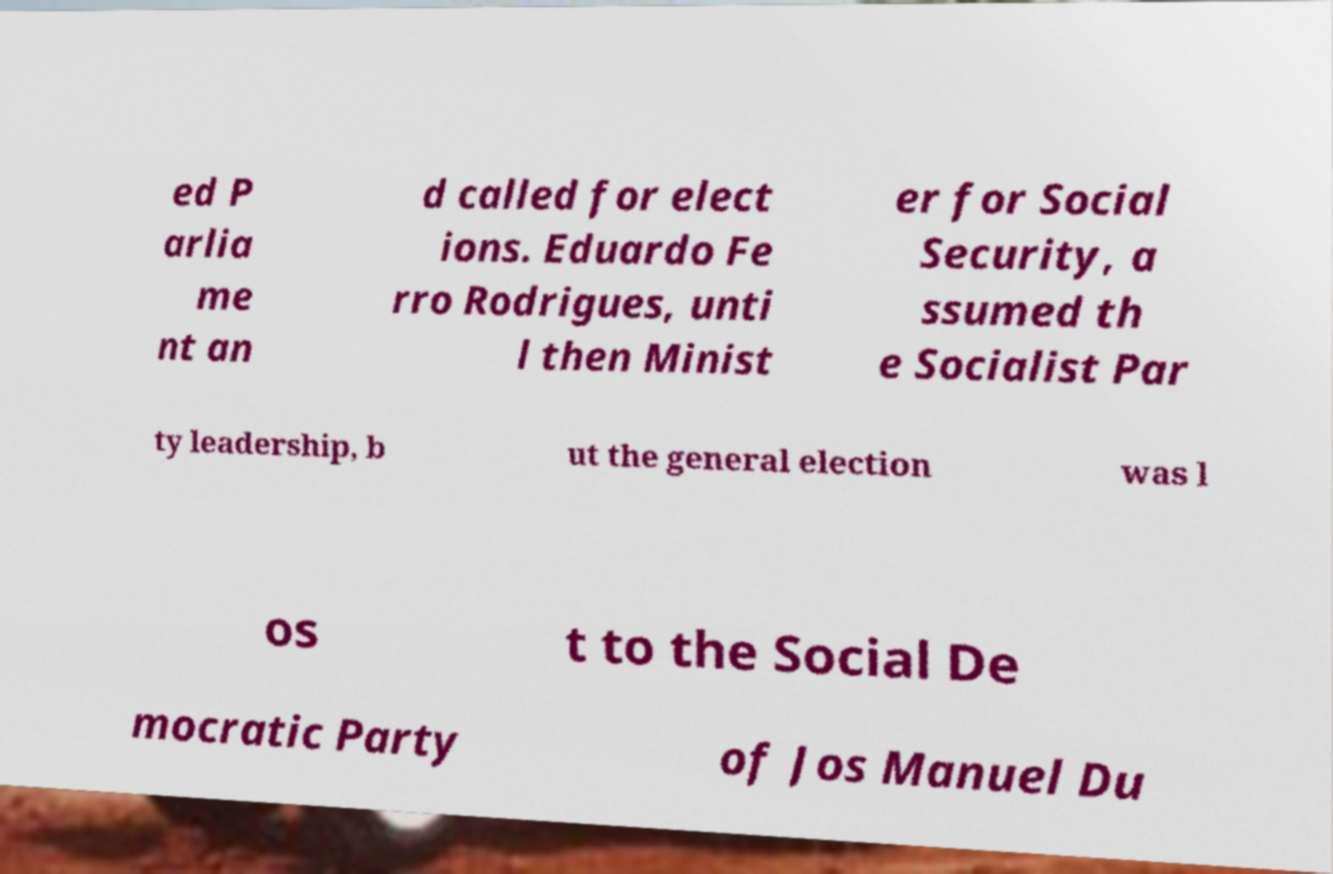Can you read and provide the text displayed in the image?This photo seems to have some interesting text. Can you extract and type it out for me? ed P arlia me nt an d called for elect ions. Eduardo Fe rro Rodrigues, unti l then Minist er for Social Security, a ssumed th e Socialist Par ty leadership, b ut the general election was l os t to the Social De mocratic Party of Jos Manuel Du 